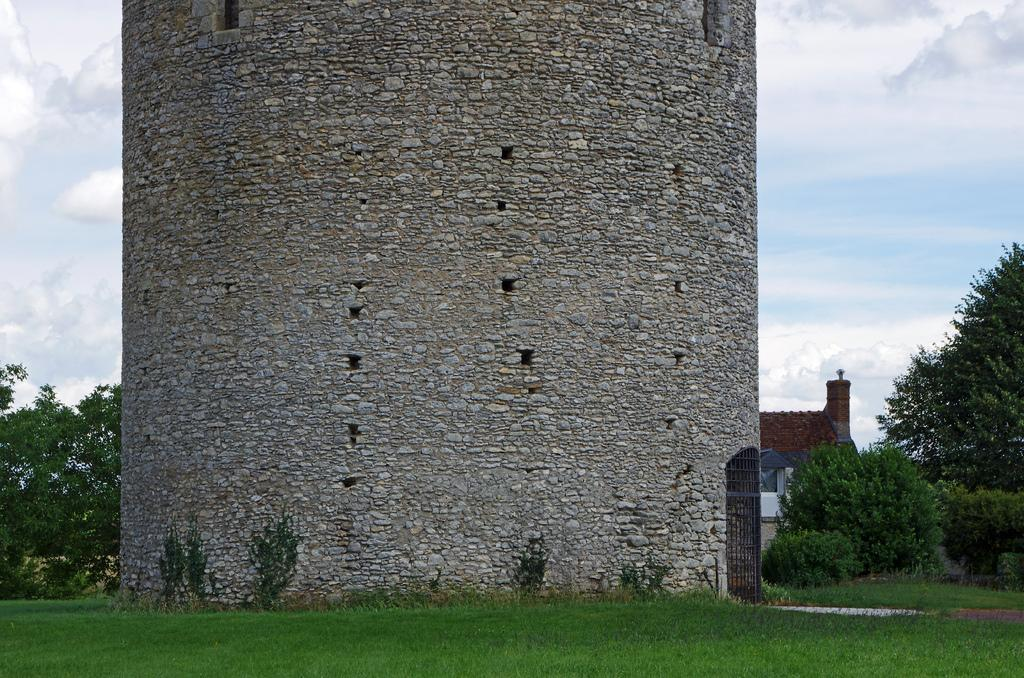What is the main structure in the center of the image? There is a tower in the center of the image. What type of vegetation can be seen in the image? There are plants in the image. What can be seen in the background of the image? There is a building and trees in the background of the image. What is visible in the sky in the image? The sky is visible in the background of the image, and there are clouds in the sky. Can you see any wilderness in the image? There is no wilderness present in the image; it features a tower, plants, a building, trees, and a sky with clouds. What type of feather can be seen on the tower in the image? There are no feathers present on the tower or anywhere else in the image. 